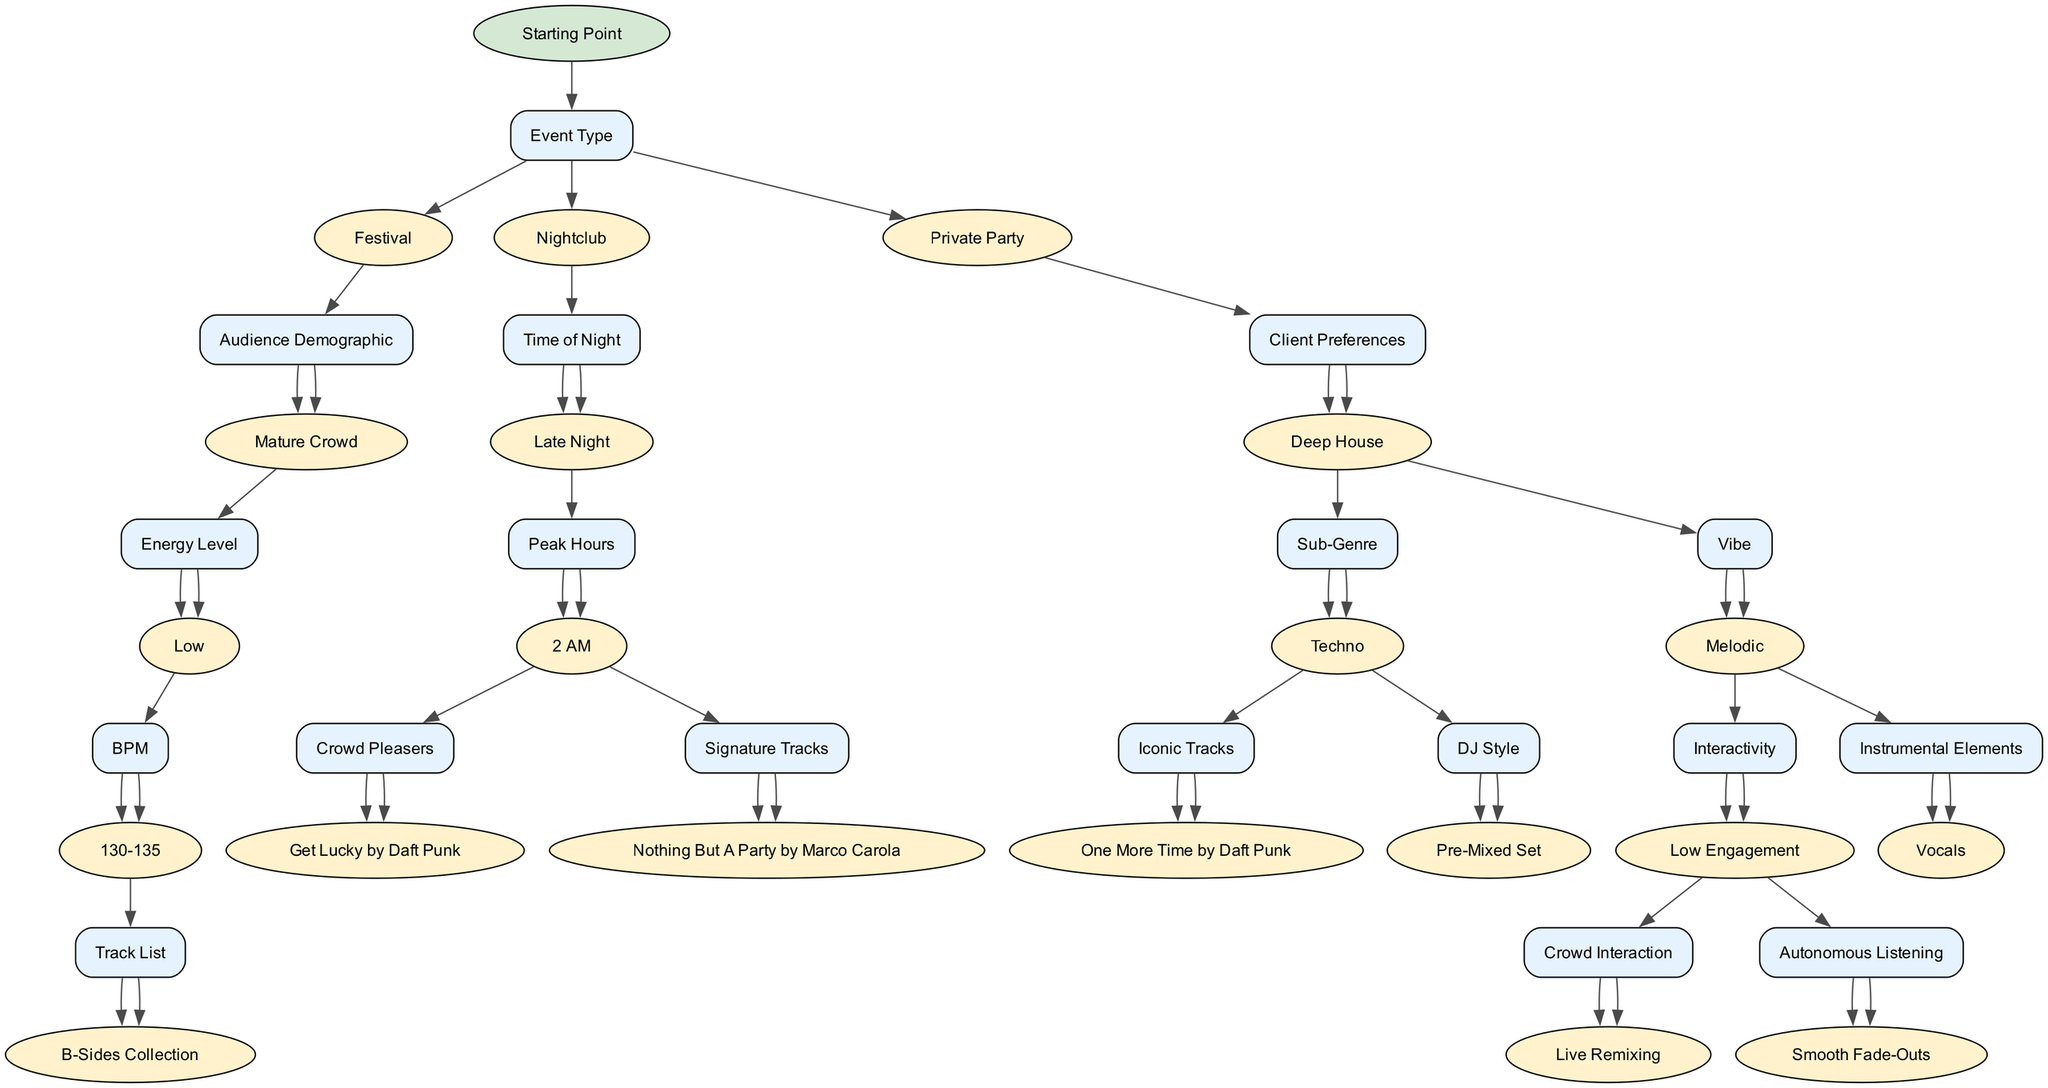What is the starting point of the decision tree? The decision tree starts with the node labeled "Starting Point". This is the root node from which all other options branch out. Since it’s the beginning of the decision-making process, it serves as the foundation for selecting music genres based on various criteria.
Answer: Starting Point How many main branches does the decision tree have? The decision tree has three main branches originating from the root node. These branches categorize the setlist curation based on "Event Type", which includes "Festival", "Nightclub", and "Private Party", leading to different subsequent nodes.
Answer: 3 If the event type is "Private Party", what will be the next node? The next node after selecting "Private Party" is "Client Preferences". This indicates that the decision-making process will focus on personal requests and choices made by the client for music selection.
Answer: Client Preferences What node follows "Energy Level" if the level is "High"? If the "Energy Level" is categorized as "High", the next node is "BPM". This indicates that a higher energy setting will lead to consideration of the beats per minute, influencing the rhythm and pace of the setlist.
Answer: BPM What sub-genre is considered if the preference is "Deep House"? If the preference is "Deep House", the next node is "Vibe". This suggests that, for this specific genre, the vibe of the music will be assessed to further refine the setlist curation process.
Answer: Vibe What tracks are classified as "Crowd Pleasers"? The nodes classified as "Crowd Pleasers" include "Levels by Avicii" and "Get Lucky by Daft Punk". These are identified as popular tracks likely to resonate with the audience, making them effective choices for engaging the crowd.
Answer: Levels by Avicii, Get Lucky by Daft Punk If the time of night is "Late Night", what is the subsequent decision node? Following "Late Night", the decision node is "Peak Hours", which helps the DJ make decisions based on the specific late-night hour, influencing the energy and types of tracks suited for that time.
Answer: Peak Hours What approach is taken for "High Engagement" in interactivity? For "High Engagement", the approach specified is "Crowd Interaction", which suggests actively involving the audience through various activities, enriching their experience during the performance.
Answer: Crowd Interaction What happens next if a track is chosen as "One More Time by Daft Punk"? If "One More Time by Daft Punk" is selected, the next step is "Prepare for Play". This implies that the track is considered ready for inclusion in the live set, indicating its acceptance in the setlist.
Answer: Prepare for Play 